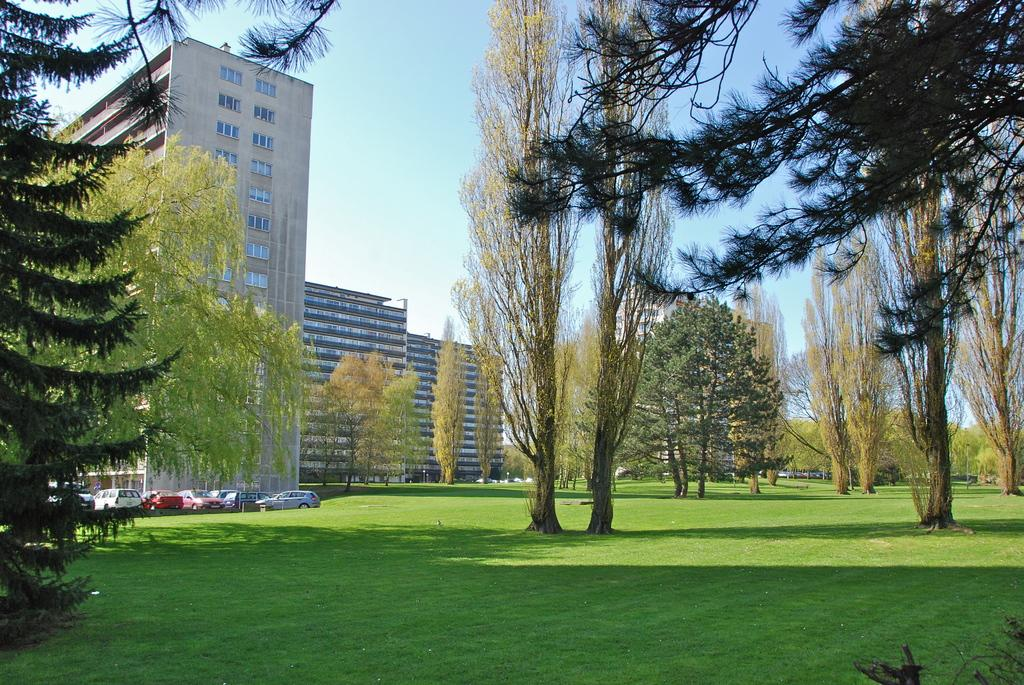What type of vegetation is present on the ground in the image? There is grass on the ground in the image. What other natural elements can be seen in the image? There are trees in the image. What man-made structures are visible in the image? There are buildings in the image. What type of vehicles are parked in the image? There are cars parked in the image. What can be seen in the background of the image? The sky is visible in the background of the image. Where is the stocking hanging in the image? There is no stocking present in the image. What type of cord is used to connect the buildings in the image? There is no cord connecting the buildings in the image; they are separate structures. 